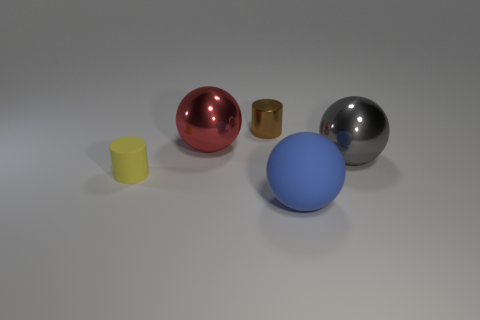How many things are either brown cylinders or tiny things behind the small rubber cylinder?
Your answer should be very brief. 1. What is the color of the small metal cylinder?
Your response must be concise. Brown. There is a big sphere on the left side of the large rubber sphere; what color is it?
Your answer should be very brief. Red. How many small yellow matte cylinders are behind the tiny brown shiny cylinder behind the large gray metallic sphere?
Your response must be concise. 0. There is a matte sphere; is it the same size as the rubber object left of the brown cylinder?
Make the answer very short. No. Is there a brown cylinder that has the same size as the brown metallic thing?
Offer a very short reply. No. What number of objects are either brown shiny cylinders or small matte objects?
Give a very brief answer. 2. There is a metal ball to the left of the big gray shiny thing; is its size the same as the ball that is in front of the rubber cylinder?
Make the answer very short. Yes. Is there a tiny metallic thing that has the same shape as the tiny yellow matte thing?
Provide a succinct answer. Yes. Is the number of large gray objects in front of the small yellow object less than the number of blue metal cubes?
Your answer should be very brief. No. 